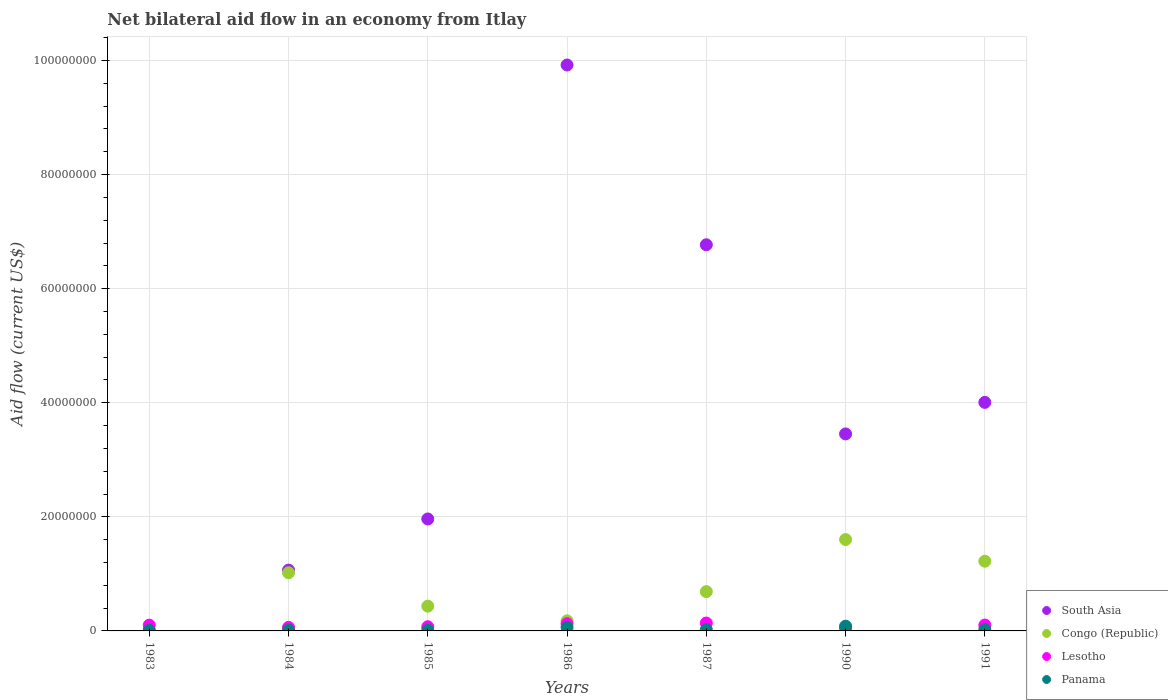Is the number of dotlines equal to the number of legend labels?
Offer a terse response. No. What is the net bilateral aid flow in South Asia in 1984?
Offer a terse response. 1.07e+07. Across all years, what is the maximum net bilateral aid flow in South Asia?
Offer a terse response. 9.92e+07. Across all years, what is the minimum net bilateral aid flow in Congo (Republic)?
Ensure brevity in your answer.  9.00e+04. What is the total net bilateral aid flow in South Asia in the graph?
Provide a short and direct response. 2.72e+08. What is the difference between the net bilateral aid flow in Panama in 1985 and that in 1990?
Make the answer very short. -7.20e+05. What is the difference between the net bilateral aid flow in Lesotho in 1984 and the net bilateral aid flow in Panama in 1990?
Keep it short and to the point. -2.10e+05. What is the average net bilateral aid flow in Lesotho per year?
Give a very brief answer. 9.24e+05. In the year 1987, what is the difference between the net bilateral aid flow in Lesotho and net bilateral aid flow in Panama?
Ensure brevity in your answer.  1.15e+06. In how many years, is the net bilateral aid flow in Congo (Republic) greater than 52000000 US$?
Offer a very short reply. 0. What is the ratio of the net bilateral aid flow in Lesotho in 1984 to that in 1990?
Provide a succinct answer. 1.41. Is the net bilateral aid flow in Congo (Republic) in 1986 less than that in 1987?
Ensure brevity in your answer.  Yes. Is the difference between the net bilateral aid flow in Lesotho in 1983 and 1987 greater than the difference between the net bilateral aid flow in Panama in 1983 and 1987?
Your answer should be compact. No. What is the difference between the highest and the lowest net bilateral aid flow in Congo (Republic)?
Provide a short and direct response. 1.59e+07. In how many years, is the net bilateral aid flow in South Asia greater than the average net bilateral aid flow in South Asia taken over all years?
Make the answer very short. 3. Is the sum of the net bilateral aid flow in Panama in 1983 and 1991 greater than the maximum net bilateral aid flow in Congo (Republic) across all years?
Provide a succinct answer. No. Does the net bilateral aid flow in Panama monotonically increase over the years?
Give a very brief answer. No. Is the net bilateral aid flow in South Asia strictly greater than the net bilateral aid flow in Panama over the years?
Give a very brief answer. No. Is the net bilateral aid flow in South Asia strictly less than the net bilateral aid flow in Lesotho over the years?
Ensure brevity in your answer.  No. How many dotlines are there?
Ensure brevity in your answer.  4. What is the difference between two consecutive major ticks on the Y-axis?
Make the answer very short. 2.00e+07. Are the values on the major ticks of Y-axis written in scientific E-notation?
Ensure brevity in your answer.  No. Does the graph contain any zero values?
Your answer should be compact. Yes. Does the graph contain grids?
Make the answer very short. Yes. How many legend labels are there?
Provide a short and direct response. 4. How are the legend labels stacked?
Offer a terse response. Vertical. What is the title of the graph?
Offer a very short reply. Net bilateral aid flow in an economy from Itlay. What is the label or title of the X-axis?
Offer a very short reply. Years. What is the label or title of the Y-axis?
Offer a terse response. Aid flow (current US$). What is the Aid flow (current US$) in South Asia in 1983?
Your response must be concise. 0. What is the Aid flow (current US$) in Congo (Republic) in 1983?
Ensure brevity in your answer.  9.00e+04. What is the Aid flow (current US$) in Lesotho in 1983?
Provide a short and direct response. 1.01e+06. What is the Aid flow (current US$) of Panama in 1983?
Ensure brevity in your answer.  1.00e+05. What is the Aid flow (current US$) of South Asia in 1984?
Provide a short and direct response. 1.07e+07. What is the Aid flow (current US$) of Congo (Republic) in 1984?
Your response must be concise. 1.02e+07. What is the Aid flow (current US$) of Lesotho in 1984?
Provide a succinct answer. 6.20e+05. What is the Aid flow (current US$) of South Asia in 1985?
Your answer should be compact. 1.96e+07. What is the Aid flow (current US$) in Congo (Republic) in 1985?
Your answer should be very brief. 4.34e+06. What is the Aid flow (current US$) of Lesotho in 1985?
Keep it short and to the point. 7.30e+05. What is the Aid flow (current US$) in Panama in 1985?
Provide a short and direct response. 1.10e+05. What is the Aid flow (current US$) of South Asia in 1986?
Provide a short and direct response. 9.92e+07. What is the Aid flow (current US$) in Congo (Republic) in 1986?
Your response must be concise. 1.77e+06. What is the Aid flow (current US$) of Lesotho in 1986?
Make the answer very short. 1.26e+06. What is the Aid flow (current US$) of Panama in 1986?
Give a very brief answer. 6.30e+05. What is the Aid flow (current US$) in South Asia in 1987?
Provide a short and direct response. 6.77e+07. What is the Aid flow (current US$) of Congo (Republic) in 1987?
Offer a very short reply. 6.89e+06. What is the Aid flow (current US$) of Lesotho in 1987?
Give a very brief answer. 1.38e+06. What is the Aid flow (current US$) of Panama in 1987?
Your answer should be very brief. 2.30e+05. What is the Aid flow (current US$) of South Asia in 1990?
Your answer should be very brief. 3.45e+07. What is the Aid flow (current US$) in Congo (Republic) in 1990?
Your answer should be compact. 1.60e+07. What is the Aid flow (current US$) of Lesotho in 1990?
Your answer should be very brief. 4.40e+05. What is the Aid flow (current US$) of Panama in 1990?
Make the answer very short. 8.30e+05. What is the Aid flow (current US$) in South Asia in 1991?
Your response must be concise. 4.01e+07. What is the Aid flow (current US$) in Congo (Republic) in 1991?
Provide a succinct answer. 1.22e+07. What is the Aid flow (current US$) in Lesotho in 1991?
Provide a short and direct response. 1.03e+06. What is the Aid flow (current US$) in Panama in 1991?
Your response must be concise. 2.20e+05. Across all years, what is the maximum Aid flow (current US$) in South Asia?
Make the answer very short. 9.92e+07. Across all years, what is the maximum Aid flow (current US$) in Congo (Republic)?
Your answer should be compact. 1.60e+07. Across all years, what is the maximum Aid flow (current US$) in Lesotho?
Your answer should be compact. 1.38e+06. Across all years, what is the maximum Aid flow (current US$) in Panama?
Your answer should be compact. 8.30e+05. Across all years, what is the minimum Aid flow (current US$) in South Asia?
Your answer should be compact. 0. Across all years, what is the minimum Aid flow (current US$) in Lesotho?
Give a very brief answer. 4.40e+05. What is the total Aid flow (current US$) in South Asia in the graph?
Offer a terse response. 2.72e+08. What is the total Aid flow (current US$) of Congo (Republic) in the graph?
Offer a very short reply. 5.15e+07. What is the total Aid flow (current US$) in Lesotho in the graph?
Give a very brief answer. 6.47e+06. What is the total Aid flow (current US$) of Panama in the graph?
Keep it short and to the point. 2.26e+06. What is the difference between the Aid flow (current US$) of Congo (Republic) in 1983 and that in 1984?
Provide a short and direct response. -1.01e+07. What is the difference between the Aid flow (current US$) in Congo (Republic) in 1983 and that in 1985?
Your response must be concise. -4.25e+06. What is the difference between the Aid flow (current US$) of Lesotho in 1983 and that in 1985?
Give a very brief answer. 2.80e+05. What is the difference between the Aid flow (current US$) in Congo (Republic) in 1983 and that in 1986?
Your response must be concise. -1.68e+06. What is the difference between the Aid flow (current US$) in Panama in 1983 and that in 1986?
Your response must be concise. -5.30e+05. What is the difference between the Aid flow (current US$) of Congo (Republic) in 1983 and that in 1987?
Provide a succinct answer. -6.80e+06. What is the difference between the Aid flow (current US$) of Lesotho in 1983 and that in 1987?
Provide a succinct answer. -3.70e+05. What is the difference between the Aid flow (current US$) of Congo (Republic) in 1983 and that in 1990?
Ensure brevity in your answer.  -1.59e+07. What is the difference between the Aid flow (current US$) of Lesotho in 1983 and that in 1990?
Provide a short and direct response. 5.70e+05. What is the difference between the Aid flow (current US$) in Panama in 1983 and that in 1990?
Your response must be concise. -7.30e+05. What is the difference between the Aid flow (current US$) in Congo (Republic) in 1983 and that in 1991?
Provide a succinct answer. -1.21e+07. What is the difference between the Aid flow (current US$) of Lesotho in 1983 and that in 1991?
Your response must be concise. -2.00e+04. What is the difference between the Aid flow (current US$) of South Asia in 1984 and that in 1985?
Provide a succinct answer. -8.97e+06. What is the difference between the Aid flow (current US$) of Congo (Republic) in 1984 and that in 1985?
Your answer should be compact. 5.86e+06. What is the difference between the Aid flow (current US$) in Lesotho in 1984 and that in 1985?
Your answer should be compact. -1.10e+05. What is the difference between the Aid flow (current US$) in Panama in 1984 and that in 1985?
Keep it short and to the point. 3.00e+04. What is the difference between the Aid flow (current US$) of South Asia in 1984 and that in 1986?
Ensure brevity in your answer.  -8.86e+07. What is the difference between the Aid flow (current US$) of Congo (Republic) in 1984 and that in 1986?
Your answer should be compact. 8.43e+06. What is the difference between the Aid flow (current US$) in Lesotho in 1984 and that in 1986?
Your answer should be compact. -6.40e+05. What is the difference between the Aid flow (current US$) in Panama in 1984 and that in 1986?
Your answer should be very brief. -4.90e+05. What is the difference between the Aid flow (current US$) of South Asia in 1984 and that in 1987?
Your answer should be compact. -5.70e+07. What is the difference between the Aid flow (current US$) in Congo (Republic) in 1984 and that in 1987?
Provide a succinct answer. 3.31e+06. What is the difference between the Aid flow (current US$) in Lesotho in 1984 and that in 1987?
Provide a succinct answer. -7.60e+05. What is the difference between the Aid flow (current US$) of South Asia in 1984 and that in 1990?
Offer a terse response. -2.39e+07. What is the difference between the Aid flow (current US$) of Congo (Republic) in 1984 and that in 1990?
Offer a very short reply. -5.82e+06. What is the difference between the Aid flow (current US$) in Panama in 1984 and that in 1990?
Offer a terse response. -6.90e+05. What is the difference between the Aid flow (current US$) of South Asia in 1984 and that in 1991?
Keep it short and to the point. -2.94e+07. What is the difference between the Aid flow (current US$) of Congo (Republic) in 1984 and that in 1991?
Provide a succinct answer. -2.02e+06. What is the difference between the Aid flow (current US$) of Lesotho in 1984 and that in 1991?
Ensure brevity in your answer.  -4.10e+05. What is the difference between the Aid flow (current US$) of South Asia in 1985 and that in 1986?
Provide a short and direct response. -7.96e+07. What is the difference between the Aid flow (current US$) of Congo (Republic) in 1985 and that in 1986?
Provide a succinct answer. 2.57e+06. What is the difference between the Aid flow (current US$) of Lesotho in 1985 and that in 1986?
Keep it short and to the point. -5.30e+05. What is the difference between the Aid flow (current US$) in Panama in 1985 and that in 1986?
Your response must be concise. -5.20e+05. What is the difference between the Aid flow (current US$) in South Asia in 1985 and that in 1987?
Provide a short and direct response. -4.81e+07. What is the difference between the Aid flow (current US$) of Congo (Republic) in 1985 and that in 1987?
Provide a succinct answer. -2.55e+06. What is the difference between the Aid flow (current US$) in Lesotho in 1985 and that in 1987?
Provide a short and direct response. -6.50e+05. What is the difference between the Aid flow (current US$) of Panama in 1985 and that in 1987?
Make the answer very short. -1.20e+05. What is the difference between the Aid flow (current US$) in South Asia in 1985 and that in 1990?
Your answer should be compact. -1.49e+07. What is the difference between the Aid flow (current US$) in Congo (Republic) in 1985 and that in 1990?
Offer a terse response. -1.17e+07. What is the difference between the Aid flow (current US$) of Lesotho in 1985 and that in 1990?
Offer a terse response. 2.90e+05. What is the difference between the Aid flow (current US$) in Panama in 1985 and that in 1990?
Ensure brevity in your answer.  -7.20e+05. What is the difference between the Aid flow (current US$) in South Asia in 1985 and that in 1991?
Provide a short and direct response. -2.04e+07. What is the difference between the Aid flow (current US$) of Congo (Republic) in 1985 and that in 1991?
Keep it short and to the point. -7.88e+06. What is the difference between the Aid flow (current US$) in Lesotho in 1985 and that in 1991?
Ensure brevity in your answer.  -3.00e+05. What is the difference between the Aid flow (current US$) of South Asia in 1986 and that in 1987?
Keep it short and to the point. 3.15e+07. What is the difference between the Aid flow (current US$) in Congo (Republic) in 1986 and that in 1987?
Your answer should be very brief. -5.12e+06. What is the difference between the Aid flow (current US$) of Lesotho in 1986 and that in 1987?
Your response must be concise. -1.20e+05. What is the difference between the Aid flow (current US$) in South Asia in 1986 and that in 1990?
Your answer should be compact. 6.47e+07. What is the difference between the Aid flow (current US$) of Congo (Republic) in 1986 and that in 1990?
Provide a short and direct response. -1.42e+07. What is the difference between the Aid flow (current US$) in Lesotho in 1986 and that in 1990?
Your answer should be compact. 8.20e+05. What is the difference between the Aid flow (current US$) of Panama in 1986 and that in 1990?
Offer a terse response. -2.00e+05. What is the difference between the Aid flow (current US$) in South Asia in 1986 and that in 1991?
Provide a succinct answer. 5.92e+07. What is the difference between the Aid flow (current US$) in Congo (Republic) in 1986 and that in 1991?
Your answer should be very brief. -1.04e+07. What is the difference between the Aid flow (current US$) in South Asia in 1987 and that in 1990?
Keep it short and to the point. 3.32e+07. What is the difference between the Aid flow (current US$) of Congo (Republic) in 1987 and that in 1990?
Offer a terse response. -9.13e+06. What is the difference between the Aid flow (current US$) in Lesotho in 1987 and that in 1990?
Provide a succinct answer. 9.40e+05. What is the difference between the Aid flow (current US$) of Panama in 1987 and that in 1990?
Your answer should be very brief. -6.00e+05. What is the difference between the Aid flow (current US$) of South Asia in 1987 and that in 1991?
Offer a very short reply. 2.76e+07. What is the difference between the Aid flow (current US$) in Congo (Republic) in 1987 and that in 1991?
Your response must be concise. -5.33e+06. What is the difference between the Aid flow (current US$) in Lesotho in 1987 and that in 1991?
Provide a short and direct response. 3.50e+05. What is the difference between the Aid flow (current US$) in South Asia in 1990 and that in 1991?
Give a very brief answer. -5.53e+06. What is the difference between the Aid flow (current US$) in Congo (Republic) in 1990 and that in 1991?
Your answer should be compact. 3.80e+06. What is the difference between the Aid flow (current US$) of Lesotho in 1990 and that in 1991?
Your response must be concise. -5.90e+05. What is the difference between the Aid flow (current US$) in Congo (Republic) in 1983 and the Aid flow (current US$) in Lesotho in 1984?
Offer a terse response. -5.30e+05. What is the difference between the Aid flow (current US$) in Congo (Republic) in 1983 and the Aid flow (current US$) in Panama in 1984?
Your answer should be compact. -5.00e+04. What is the difference between the Aid flow (current US$) in Lesotho in 1983 and the Aid flow (current US$) in Panama in 1984?
Make the answer very short. 8.70e+05. What is the difference between the Aid flow (current US$) in Congo (Republic) in 1983 and the Aid flow (current US$) in Lesotho in 1985?
Keep it short and to the point. -6.40e+05. What is the difference between the Aid flow (current US$) in Congo (Republic) in 1983 and the Aid flow (current US$) in Lesotho in 1986?
Offer a terse response. -1.17e+06. What is the difference between the Aid flow (current US$) in Congo (Republic) in 1983 and the Aid flow (current US$) in Panama in 1986?
Your answer should be very brief. -5.40e+05. What is the difference between the Aid flow (current US$) in Lesotho in 1983 and the Aid flow (current US$) in Panama in 1986?
Your answer should be very brief. 3.80e+05. What is the difference between the Aid flow (current US$) of Congo (Republic) in 1983 and the Aid flow (current US$) of Lesotho in 1987?
Offer a very short reply. -1.29e+06. What is the difference between the Aid flow (current US$) in Lesotho in 1983 and the Aid flow (current US$) in Panama in 1987?
Provide a succinct answer. 7.80e+05. What is the difference between the Aid flow (current US$) of Congo (Republic) in 1983 and the Aid flow (current US$) of Lesotho in 1990?
Ensure brevity in your answer.  -3.50e+05. What is the difference between the Aid flow (current US$) in Congo (Republic) in 1983 and the Aid flow (current US$) in Panama in 1990?
Provide a succinct answer. -7.40e+05. What is the difference between the Aid flow (current US$) in Lesotho in 1983 and the Aid flow (current US$) in Panama in 1990?
Give a very brief answer. 1.80e+05. What is the difference between the Aid flow (current US$) in Congo (Republic) in 1983 and the Aid flow (current US$) in Lesotho in 1991?
Your answer should be very brief. -9.40e+05. What is the difference between the Aid flow (current US$) in Lesotho in 1983 and the Aid flow (current US$) in Panama in 1991?
Give a very brief answer. 7.90e+05. What is the difference between the Aid flow (current US$) in South Asia in 1984 and the Aid flow (current US$) in Congo (Republic) in 1985?
Provide a short and direct response. 6.32e+06. What is the difference between the Aid flow (current US$) of South Asia in 1984 and the Aid flow (current US$) of Lesotho in 1985?
Keep it short and to the point. 9.93e+06. What is the difference between the Aid flow (current US$) of South Asia in 1984 and the Aid flow (current US$) of Panama in 1985?
Ensure brevity in your answer.  1.06e+07. What is the difference between the Aid flow (current US$) in Congo (Republic) in 1984 and the Aid flow (current US$) in Lesotho in 1985?
Ensure brevity in your answer.  9.47e+06. What is the difference between the Aid flow (current US$) of Congo (Republic) in 1984 and the Aid flow (current US$) of Panama in 1985?
Offer a very short reply. 1.01e+07. What is the difference between the Aid flow (current US$) in Lesotho in 1984 and the Aid flow (current US$) in Panama in 1985?
Your answer should be very brief. 5.10e+05. What is the difference between the Aid flow (current US$) in South Asia in 1984 and the Aid flow (current US$) in Congo (Republic) in 1986?
Keep it short and to the point. 8.89e+06. What is the difference between the Aid flow (current US$) of South Asia in 1984 and the Aid flow (current US$) of Lesotho in 1986?
Your response must be concise. 9.40e+06. What is the difference between the Aid flow (current US$) of South Asia in 1984 and the Aid flow (current US$) of Panama in 1986?
Offer a very short reply. 1.00e+07. What is the difference between the Aid flow (current US$) in Congo (Republic) in 1984 and the Aid flow (current US$) in Lesotho in 1986?
Ensure brevity in your answer.  8.94e+06. What is the difference between the Aid flow (current US$) of Congo (Republic) in 1984 and the Aid flow (current US$) of Panama in 1986?
Provide a succinct answer. 9.57e+06. What is the difference between the Aid flow (current US$) of South Asia in 1984 and the Aid flow (current US$) of Congo (Republic) in 1987?
Make the answer very short. 3.77e+06. What is the difference between the Aid flow (current US$) of South Asia in 1984 and the Aid flow (current US$) of Lesotho in 1987?
Offer a terse response. 9.28e+06. What is the difference between the Aid flow (current US$) of South Asia in 1984 and the Aid flow (current US$) of Panama in 1987?
Offer a very short reply. 1.04e+07. What is the difference between the Aid flow (current US$) in Congo (Republic) in 1984 and the Aid flow (current US$) in Lesotho in 1987?
Provide a succinct answer. 8.82e+06. What is the difference between the Aid flow (current US$) in Congo (Republic) in 1984 and the Aid flow (current US$) in Panama in 1987?
Ensure brevity in your answer.  9.97e+06. What is the difference between the Aid flow (current US$) of Lesotho in 1984 and the Aid flow (current US$) of Panama in 1987?
Your answer should be compact. 3.90e+05. What is the difference between the Aid flow (current US$) of South Asia in 1984 and the Aid flow (current US$) of Congo (Republic) in 1990?
Provide a succinct answer. -5.36e+06. What is the difference between the Aid flow (current US$) of South Asia in 1984 and the Aid flow (current US$) of Lesotho in 1990?
Offer a very short reply. 1.02e+07. What is the difference between the Aid flow (current US$) in South Asia in 1984 and the Aid flow (current US$) in Panama in 1990?
Provide a short and direct response. 9.83e+06. What is the difference between the Aid flow (current US$) in Congo (Republic) in 1984 and the Aid flow (current US$) in Lesotho in 1990?
Offer a terse response. 9.76e+06. What is the difference between the Aid flow (current US$) in Congo (Republic) in 1984 and the Aid flow (current US$) in Panama in 1990?
Keep it short and to the point. 9.37e+06. What is the difference between the Aid flow (current US$) in South Asia in 1984 and the Aid flow (current US$) in Congo (Republic) in 1991?
Keep it short and to the point. -1.56e+06. What is the difference between the Aid flow (current US$) of South Asia in 1984 and the Aid flow (current US$) of Lesotho in 1991?
Offer a very short reply. 9.63e+06. What is the difference between the Aid flow (current US$) in South Asia in 1984 and the Aid flow (current US$) in Panama in 1991?
Provide a succinct answer. 1.04e+07. What is the difference between the Aid flow (current US$) of Congo (Republic) in 1984 and the Aid flow (current US$) of Lesotho in 1991?
Your response must be concise. 9.17e+06. What is the difference between the Aid flow (current US$) of Congo (Republic) in 1984 and the Aid flow (current US$) of Panama in 1991?
Offer a very short reply. 9.98e+06. What is the difference between the Aid flow (current US$) of South Asia in 1985 and the Aid flow (current US$) of Congo (Republic) in 1986?
Keep it short and to the point. 1.79e+07. What is the difference between the Aid flow (current US$) of South Asia in 1985 and the Aid flow (current US$) of Lesotho in 1986?
Offer a terse response. 1.84e+07. What is the difference between the Aid flow (current US$) in South Asia in 1985 and the Aid flow (current US$) in Panama in 1986?
Provide a short and direct response. 1.90e+07. What is the difference between the Aid flow (current US$) in Congo (Republic) in 1985 and the Aid flow (current US$) in Lesotho in 1986?
Give a very brief answer. 3.08e+06. What is the difference between the Aid flow (current US$) in Congo (Republic) in 1985 and the Aid flow (current US$) in Panama in 1986?
Keep it short and to the point. 3.71e+06. What is the difference between the Aid flow (current US$) of South Asia in 1985 and the Aid flow (current US$) of Congo (Republic) in 1987?
Ensure brevity in your answer.  1.27e+07. What is the difference between the Aid flow (current US$) in South Asia in 1985 and the Aid flow (current US$) in Lesotho in 1987?
Give a very brief answer. 1.82e+07. What is the difference between the Aid flow (current US$) in South Asia in 1985 and the Aid flow (current US$) in Panama in 1987?
Make the answer very short. 1.94e+07. What is the difference between the Aid flow (current US$) in Congo (Republic) in 1985 and the Aid flow (current US$) in Lesotho in 1987?
Provide a succinct answer. 2.96e+06. What is the difference between the Aid flow (current US$) of Congo (Republic) in 1985 and the Aid flow (current US$) of Panama in 1987?
Make the answer very short. 4.11e+06. What is the difference between the Aid flow (current US$) in Lesotho in 1985 and the Aid flow (current US$) in Panama in 1987?
Give a very brief answer. 5.00e+05. What is the difference between the Aid flow (current US$) of South Asia in 1985 and the Aid flow (current US$) of Congo (Republic) in 1990?
Offer a very short reply. 3.61e+06. What is the difference between the Aid flow (current US$) in South Asia in 1985 and the Aid flow (current US$) in Lesotho in 1990?
Your response must be concise. 1.92e+07. What is the difference between the Aid flow (current US$) of South Asia in 1985 and the Aid flow (current US$) of Panama in 1990?
Your response must be concise. 1.88e+07. What is the difference between the Aid flow (current US$) of Congo (Republic) in 1985 and the Aid flow (current US$) of Lesotho in 1990?
Your response must be concise. 3.90e+06. What is the difference between the Aid flow (current US$) in Congo (Republic) in 1985 and the Aid flow (current US$) in Panama in 1990?
Your response must be concise. 3.51e+06. What is the difference between the Aid flow (current US$) in South Asia in 1985 and the Aid flow (current US$) in Congo (Republic) in 1991?
Provide a succinct answer. 7.41e+06. What is the difference between the Aid flow (current US$) of South Asia in 1985 and the Aid flow (current US$) of Lesotho in 1991?
Provide a short and direct response. 1.86e+07. What is the difference between the Aid flow (current US$) of South Asia in 1985 and the Aid flow (current US$) of Panama in 1991?
Your answer should be compact. 1.94e+07. What is the difference between the Aid flow (current US$) of Congo (Republic) in 1985 and the Aid flow (current US$) of Lesotho in 1991?
Offer a very short reply. 3.31e+06. What is the difference between the Aid flow (current US$) of Congo (Republic) in 1985 and the Aid flow (current US$) of Panama in 1991?
Offer a terse response. 4.12e+06. What is the difference between the Aid flow (current US$) of Lesotho in 1985 and the Aid flow (current US$) of Panama in 1991?
Your answer should be very brief. 5.10e+05. What is the difference between the Aid flow (current US$) in South Asia in 1986 and the Aid flow (current US$) in Congo (Republic) in 1987?
Your response must be concise. 9.23e+07. What is the difference between the Aid flow (current US$) of South Asia in 1986 and the Aid flow (current US$) of Lesotho in 1987?
Your answer should be very brief. 9.78e+07. What is the difference between the Aid flow (current US$) in South Asia in 1986 and the Aid flow (current US$) in Panama in 1987?
Ensure brevity in your answer.  9.90e+07. What is the difference between the Aid flow (current US$) in Congo (Republic) in 1986 and the Aid flow (current US$) in Lesotho in 1987?
Your answer should be compact. 3.90e+05. What is the difference between the Aid flow (current US$) in Congo (Republic) in 1986 and the Aid flow (current US$) in Panama in 1987?
Provide a short and direct response. 1.54e+06. What is the difference between the Aid flow (current US$) of Lesotho in 1986 and the Aid flow (current US$) of Panama in 1987?
Your answer should be very brief. 1.03e+06. What is the difference between the Aid flow (current US$) in South Asia in 1986 and the Aid flow (current US$) in Congo (Republic) in 1990?
Make the answer very short. 8.32e+07. What is the difference between the Aid flow (current US$) in South Asia in 1986 and the Aid flow (current US$) in Lesotho in 1990?
Your response must be concise. 9.88e+07. What is the difference between the Aid flow (current US$) of South Asia in 1986 and the Aid flow (current US$) of Panama in 1990?
Offer a very short reply. 9.84e+07. What is the difference between the Aid flow (current US$) of Congo (Republic) in 1986 and the Aid flow (current US$) of Lesotho in 1990?
Your answer should be compact. 1.33e+06. What is the difference between the Aid flow (current US$) of Congo (Republic) in 1986 and the Aid flow (current US$) of Panama in 1990?
Offer a very short reply. 9.40e+05. What is the difference between the Aid flow (current US$) of South Asia in 1986 and the Aid flow (current US$) of Congo (Republic) in 1991?
Offer a very short reply. 8.70e+07. What is the difference between the Aid flow (current US$) of South Asia in 1986 and the Aid flow (current US$) of Lesotho in 1991?
Keep it short and to the point. 9.82e+07. What is the difference between the Aid flow (current US$) of South Asia in 1986 and the Aid flow (current US$) of Panama in 1991?
Ensure brevity in your answer.  9.90e+07. What is the difference between the Aid flow (current US$) in Congo (Republic) in 1986 and the Aid flow (current US$) in Lesotho in 1991?
Give a very brief answer. 7.40e+05. What is the difference between the Aid flow (current US$) of Congo (Republic) in 1986 and the Aid flow (current US$) of Panama in 1991?
Your answer should be very brief. 1.55e+06. What is the difference between the Aid flow (current US$) of Lesotho in 1986 and the Aid flow (current US$) of Panama in 1991?
Your answer should be compact. 1.04e+06. What is the difference between the Aid flow (current US$) in South Asia in 1987 and the Aid flow (current US$) in Congo (Republic) in 1990?
Your response must be concise. 5.17e+07. What is the difference between the Aid flow (current US$) of South Asia in 1987 and the Aid flow (current US$) of Lesotho in 1990?
Offer a terse response. 6.73e+07. What is the difference between the Aid flow (current US$) in South Asia in 1987 and the Aid flow (current US$) in Panama in 1990?
Keep it short and to the point. 6.69e+07. What is the difference between the Aid flow (current US$) of Congo (Republic) in 1987 and the Aid flow (current US$) of Lesotho in 1990?
Provide a short and direct response. 6.45e+06. What is the difference between the Aid flow (current US$) in Congo (Republic) in 1987 and the Aid flow (current US$) in Panama in 1990?
Offer a terse response. 6.06e+06. What is the difference between the Aid flow (current US$) in Lesotho in 1987 and the Aid flow (current US$) in Panama in 1990?
Provide a short and direct response. 5.50e+05. What is the difference between the Aid flow (current US$) of South Asia in 1987 and the Aid flow (current US$) of Congo (Republic) in 1991?
Keep it short and to the point. 5.55e+07. What is the difference between the Aid flow (current US$) in South Asia in 1987 and the Aid flow (current US$) in Lesotho in 1991?
Give a very brief answer. 6.67e+07. What is the difference between the Aid flow (current US$) in South Asia in 1987 and the Aid flow (current US$) in Panama in 1991?
Offer a terse response. 6.75e+07. What is the difference between the Aid flow (current US$) of Congo (Republic) in 1987 and the Aid flow (current US$) of Lesotho in 1991?
Your answer should be compact. 5.86e+06. What is the difference between the Aid flow (current US$) in Congo (Republic) in 1987 and the Aid flow (current US$) in Panama in 1991?
Your response must be concise. 6.67e+06. What is the difference between the Aid flow (current US$) in Lesotho in 1987 and the Aid flow (current US$) in Panama in 1991?
Provide a short and direct response. 1.16e+06. What is the difference between the Aid flow (current US$) in South Asia in 1990 and the Aid flow (current US$) in Congo (Republic) in 1991?
Offer a terse response. 2.23e+07. What is the difference between the Aid flow (current US$) in South Asia in 1990 and the Aid flow (current US$) in Lesotho in 1991?
Ensure brevity in your answer.  3.35e+07. What is the difference between the Aid flow (current US$) in South Asia in 1990 and the Aid flow (current US$) in Panama in 1991?
Your answer should be very brief. 3.43e+07. What is the difference between the Aid flow (current US$) in Congo (Republic) in 1990 and the Aid flow (current US$) in Lesotho in 1991?
Your answer should be compact. 1.50e+07. What is the difference between the Aid flow (current US$) of Congo (Republic) in 1990 and the Aid flow (current US$) of Panama in 1991?
Provide a succinct answer. 1.58e+07. What is the average Aid flow (current US$) in South Asia per year?
Ensure brevity in your answer.  3.88e+07. What is the average Aid flow (current US$) in Congo (Republic) per year?
Provide a succinct answer. 7.36e+06. What is the average Aid flow (current US$) of Lesotho per year?
Your response must be concise. 9.24e+05. What is the average Aid flow (current US$) in Panama per year?
Make the answer very short. 3.23e+05. In the year 1983, what is the difference between the Aid flow (current US$) in Congo (Republic) and Aid flow (current US$) in Lesotho?
Ensure brevity in your answer.  -9.20e+05. In the year 1983, what is the difference between the Aid flow (current US$) of Lesotho and Aid flow (current US$) of Panama?
Ensure brevity in your answer.  9.10e+05. In the year 1984, what is the difference between the Aid flow (current US$) in South Asia and Aid flow (current US$) in Lesotho?
Provide a short and direct response. 1.00e+07. In the year 1984, what is the difference between the Aid flow (current US$) of South Asia and Aid flow (current US$) of Panama?
Make the answer very short. 1.05e+07. In the year 1984, what is the difference between the Aid flow (current US$) of Congo (Republic) and Aid flow (current US$) of Lesotho?
Your response must be concise. 9.58e+06. In the year 1984, what is the difference between the Aid flow (current US$) of Congo (Republic) and Aid flow (current US$) of Panama?
Your answer should be very brief. 1.01e+07. In the year 1985, what is the difference between the Aid flow (current US$) in South Asia and Aid flow (current US$) in Congo (Republic)?
Make the answer very short. 1.53e+07. In the year 1985, what is the difference between the Aid flow (current US$) in South Asia and Aid flow (current US$) in Lesotho?
Offer a terse response. 1.89e+07. In the year 1985, what is the difference between the Aid flow (current US$) of South Asia and Aid flow (current US$) of Panama?
Your answer should be compact. 1.95e+07. In the year 1985, what is the difference between the Aid flow (current US$) of Congo (Republic) and Aid flow (current US$) of Lesotho?
Your response must be concise. 3.61e+06. In the year 1985, what is the difference between the Aid flow (current US$) of Congo (Republic) and Aid flow (current US$) of Panama?
Provide a short and direct response. 4.23e+06. In the year 1985, what is the difference between the Aid flow (current US$) of Lesotho and Aid flow (current US$) of Panama?
Keep it short and to the point. 6.20e+05. In the year 1986, what is the difference between the Aid flow (current US$) in South Asia and Aid flow (current US$) in Congo (Republic)?
Ensure brevity in your answer.  9.74e+07. In the year 1986, what is the difference between the Aid flow (current US$) in South Asia and Aid flow (current US$) in Lesotho?
Give a very brief answer. 9.80e+07. In the year 1986, what is the difference between the Aid flow (current US$) of South Asia and Aid flow (current US$) of Panama?
Ensure brevity in your answer.  9.86e+07. In the year 1986, what is the difference between the Aid flow (current US$) of Congo (Republic) and Aid flow (current US$) of Lesotho?
Provide a short and direct response. 5.10e+05. In the year 1986, what is the difference between the Aid flow (current US$) in Congo (Republic) and Aid flow (current US$) in Panama?
Offer a very short reply. 1.14e+06. In the year 1986, what is the difference between the Aid flow (current US$) of Lesotho and Aid flow (current US$) of Panama?
Give a very brief answer. 6.30e+05. In the year 1987, what is the difference between the Aid flow (current US$) in South Asia and Aid flow (current US$) in Congo (Republic)?
Give a very brief answer. 6.08e+07. In the year 1987, what is the difference between the Aid flow (current US$) of South Asia and Aid flow (current US$) of Lesotho?
Your answer should be compact. 6.63e+07. In the year 1987, what is the difference between the Aid flow (current US$) in South Asia and Aid flow (current US$) in Panama?
Offer a terse response. 6.75e+07. In the year 1987, what is the difference between the Aid flow (current US$) in Congo (Republic) and Aid flow (current US$) in Lesotho?
Your answer should be very brief. 5.51e+06. In the year 1987, what is the difference between the Aid flow (current US$) of Congo (Republic) and Aid flow (current US$) of Panama?
Provide a succinct answer. 6.66e+06. In the year 1987, what is the difference between the Aid flow (current US$) of Lesotho and Aid flow (current US$) of Panama?
Your answer should be compact. 1.15e+06. In the year 1990, what is the difference between the Aid flow (current US$) of South Asia and Aid flow (current US$) of Congo (Republic)?
Your response must be concise. 1.85e+07. In the year 1990, what is the difference between the Aid flow (current US$) in South Asia and Aid flow (current US$) in Lesotho?
Give a very brief answer. 3.41e+07. In the year 1990, what is the difference between the Aid flow (current US$) of South Asia and Aid flow (current US$) of Panama?
Provide a succinct answer. 3.37e+07. In the year 1990, what is the difference between the Aid flow (current US$) of Congo (Republic) and Aid flow (current US$) of Lesotho?
Keep it short and to the point. 1.56e+07. In the year 1990, what is the difference between the Aid flow (current US$) in Congo (Republic) and Aid flow (current US$) in Panama?
Make the answer very short. 1.52e+07. In the year 1990, what is the difference between the Aid flow (current US$) in Lesotho and Aid flow (current US$) in Panama?
Offer a very short reply. -3.90e+05. In the year 1991, what is the difference between the Aid flow (current US$) in South Asia and Aid flow (current US$) in Congo (Republic)?
Your answer should be very brief. 2.78e+07. In the year 1991, what is the difference between the Aid flow (current US$) in South Asia and Aid flow (current US$) in Lesotho?
Offer a very short reply. 3.90e+07. In the year 1991, what is the difference between the Aid flow (current US$) in South Asia and Aid flow (current US$) in Panama?
Provide a short and direct response. 3.98e+07. In the year 1991, what is the difference between the Aid flow (current US$) of Congo (Republic) and Aid flow (current US$) of Lesotho?
Keep it short and to the point. 1.12e+07. In the year 1991, what is the difference between the Aid flow (current US$) of Lesotho and Aid flow (current US$) of Panama?
Your answer should be very brief. 8.10e+05. What is the ratio of the Aid flow (current US$) in Congo (Republic) in 1983 to that in 1984?
Your response must be concise. 0.01. What is the ratio of the Aid flow (current US$) in Lesotho in 1983 to that in 1984?
Your answer should be compact. 1.63. What is the ratio of the Aid flow (current US$) of Congo (Republic) in 1983 to that in 1985?
Offer a very short reply. 0.02. What is the ratio of the Aid flow (current US$) in Lesotho in 1983 to that in 1985?
Your answer should be compact. 1.38. What is the ratio of the Aid flow (current US$) in Congo (Republic) in 1983 to that in 1986?
Keep it short and to the point. 0.05. What is the ratio of the Aid flow (current US$) of Lesotho in 1983 to that in 1986?
Keep it short and to the point. 0.8. What is the ratio of the Aid flow (current US$) of Panama in 1983 to that in 1986?
Make the answer very short. 0.16. What is the ratio of the Aid flow (current US$) of Congo (Republic) in 1983 to that in 1987?
Provide a succinct answer. 0.01. What is the ratio of the Aid flow (current US$) in Lesotho in 1983 to that in 1987?
Your answer should be compact. 0.73. What is the ratio of the Aid flow (current US$) in Panama in 1983 to that in 1987?
Give a very brief answer. 0.43. What is the ratio of the Aid flow (current US$) in Congo (Republic) in 1983 to that in 1990?
Your response must be concise. 0.01. What is the ratio of the Aid flow (current US$) in Lesotho in 1983 to that in 1990?
Your answer should be very brief. 2.3. What is the ratio of the Aid flow (current US$) of Panama in 1983 to that in 1990?
Your response must be concise. 0.12. What is the ratio of the Aid flow (current US$) in Congo (Republic) in 1983 to that in 1991?
Make the answer very short. 0.01. What is the ratio of the Aid flow (current US$) in Lesotho in 1983 to that in 1991?
Your response must be concise. 0.98. What is the ratio of the Aid flow (current US$) in Panama in 1983 to that in 1991?
Provide a short and direct response. 0.45. What is the ratio of the Aid flow (current US$) of South Asia in 1984 to that in 1985?
Offer a terse response. 0.54. What is the ratio of the Aid flow (current US$) in Congo (Republic) in 1984 to that in 1985?
Provide a succinct answer. 2.35. What is the ratio of the Aid flow (current US$) in Lesotho in 1984 to that in 1985?
Ensure brevity in your answer.  0.85. What is the ratio of the Aid flow (current US$) of Panama in 1984 to that in 1985?
Offer a very short reply. 1.27. What is the ratio of the Aid flow (current US$) in South Asia in 1984 to that in 1986?
Offer a terse response. 0.11. What is the ratio of the Aid flow (current US$) in Congo (Republic) in 1984 to that in 1986?
Offer a very short reply. 5.76. What is the ratio of the Aid flow (current US$) of Lesotho in 1984 to that in 1986?
Provide a short and direct response. 0.49. What is the ratio of the Aid flow (current US$) in Panama in 1984 to that in 1986?
Ensure brevity in your answer.  0.22. What is the ratio of the Aid flow (current US$) in South Asia in 1984 to that in 1987?
Give a very brief answer. 0.16. What is the ratio of the Aid flow (current US$) in Congo (Republic) in 1984 to that in 1987?
Offer a very short reply. 1.48. What is the ratio of the Aid flow (current US$) in Lesotho in 1984 to that in 1987?
Provide a succinct answer. 0.45. What is the ratio of the Aid flow (current US$) in Panama in 1984 to that in 1987?
Offer a terse response. 0.61. What is the ratio of the Aid flow (current US$) in South Asia in 1984 to that in 1990?
Give a very brief answer. 0.31. What is the ratio of the Aid flow (current US$) of Congo (Republic) in 1984 to that in 1990?
Give a very brief answer. 0.64. What is the ratio of the Aid flow (current US$) in Lesotho in 1984 to that in 1990?
Provide a short and direct response. 1.41. What is the ratio of the Aid flow (current US$) in Panama in 1984 to that in 1990?
Your response must be concise. 0.17. What is the ratio of the Aid flow (current US$) of South Asia in 1984 to that in 1991?
Make the answer very short. 0.27. What is the ratio of the Aid flow (current US$) in Congo (Republic) in 1984 to that in 1991?
Your answer should be very brief. 0.83. What is the ratio of the Aid flow (current US$) of Lesotho in 1984 to that in 1991?
Your response must be concise. 0.6. What is the ratio of the Aid flow (current US$) of Panama in 1984 to that in 1991?
Make the answer very short. 0.64. What is the ratio of the Aid flow (current US$) in South Asia in 1985 to that in 1986?
Give a very brief answer. 0.2. What is the ratio of the Aid flow (current US$) in Congo (Republic) in 1985 to that in 1986?
Offer a terse response. 2.45. What is the ratio of the Aid flow (current US$) in Lesotho in 1985 to that in 1986?
Keep it short and to the point. 0.58. What is the ratio of the Aid flow (current US$) in Panama in 1985 to that in 1986?
Ensure brevity in your answer.  0.17. What is the ratio of the Aid flow (current US$) of South Asia in 1985 to that in 1987?
Offer a very short reply. 0.29. What is the ratio of the Aid flow (current US$) in Congo (Republic) in 1985 to that in 1987?
Offer a terse response. 0.63. What is the ratio of the Aid flow (current US$) in Lesotho in 1985 to that in 1987?
Make the answer very short. 0.53. What is the ratio of the Aid flow (current US$) of Panama in 1985 to that in 1987?
Your answer should be compact. 0.48. What is the ratio of the Aid flow (current US$) of South Asia in 1985 to that in 1990?
Offer a very short reply. 0.57. What is the ratio of the Aid flow (current US$) in Congo (Republic) in 1985 to that in 1990?
Provide a short and direct response. 0.27. What is the ratio of the Aid flow (current US$) of Lesotho in 1985 to that in 1990?
Give a very brief answer. 1.66. What is the ratio of the Aid flow (current US$) of Panama in 1985 to that in 1990?
Offer a very short reply. 0.13. What is the ratio of the Aid flow (current US$) of South Asia in 1985 to that in 1991?
Ensure brevity in your answer.  0.49. What is the ratio of the Aid flow (current US$) in Congo (Republic) in 1985 to that in 1991?
Provide a short and direct response. 0.36. What is the ratio of the Aid flow (current US$) in Lesotho in 1985 to that in 1991?
Keep it short and to the point. 0.71. What is the ratio of the Aid flow (current US$) of South Asia in 1986 to that in 1987?
Make the answer very short. 1.47. What is the ratio of the Aid flow (current US$) of Congo (Republic) in 1986 to that in 1987?
Provide a succinct answer. 0.26. What is the ratio of the Aid flow (current US$) in Panama in 1986 to that in 1987?
Your response must be concise. 2.74. What is the ratio of the Aid flow (current US$) of South Asia in 1986 to that in 1990?
Give a very brief answer. 2.87. What is the ratio of the Aid flow (current US$) of Congo (Republic) in 1986 to that in 1990?
Offer a very short reply. 0.11. What is the ratio of the Aid flow (current US$) in Lesotho in 1986 to that in 1990?
Your response must be concise. 2.86. What is the ratio of the Aid flow (current US$) in Panama in 1986 to that in 1990?
Offer a terse response. 0.76. What is the ratio of the Aid flow (current US$) of South Asia in 1986 to that in 1991?
Your answer should be compact. 2.48. What is the ratio of the Aid flow (current US$) in Congo (Republic) in 1986 to that in 1991?
Ensure brevity in your answer.  0.14. What is the ratio of the Aid flow (current US$) of Lesotho in 1986 to that in 1991?
Provide a short and direct response. 1.22. What is the ratio of the Aid flow (current US$) of Panama in 1986 to that in 1991?
Provide a succinct answer. 2.86. What is the ratio of the Aid flow (current US$) of South Asia in 1987 to that in 1990?
Give a very brief answer. 1.96. What is the ratio of the Aid flow (current US$) in Congo (Republic) in 1987 to that in 1990?
Ensure brevity in your answer.  0.43. What is the ratio of the Aid flow (current US$) in Lesotho in 1987 to that in 1990?
Ensure brevity in your answer.  3.14. What is the ratio of the Aid flow (current US$) of Panama in 1987 to that in 1990?
Offer a terse response. 0.28. What is the ratio of the Aid flow (current US$) in South Asia in 1987 to that in 1991?
Offer a very short reply. 1.69. What is the ratio of the Aid flow (current US$) in Congo (Republic) in 1987 to that in 1991?
Keep it short and to the point. 0.56. What is the ratio of the Aid flow (current US$) in Lesotho in 1987 to that in 1991?
Make the answer very short. 1.34. What is the ratio of the Aid flow (current US$) in Panama in 1987 to that in 1991?
Give a very brief answer. 1.05. What is the ratio of the Aid flow (current US$) of South Asia in 1990 to that in 1991?
Offer a terse response. 0.86. What is the ratio of the Aid flow (current US$) in Congo (Republic) in 1990 to that in 1991?
Your response must be concise. 1.31. What is the ratio of the Aid flow (current US$) of Lesotho in 1990 to that in 1991?
Offer a terse response. 0.43. What is the ratio of the Aid flow (current US$) in Panama in 1990 to that in 1991?
Offer a very short reply. 3.77. What is the difference between the highest and the second highest Aid flow (current US$) in South Asia?
Your answer should be compact. 3.15e+07. What is the difference between the highest and the second highest Aid flow (current US$) of Congo (Republic)?
Make the answer very short. 3.80e+06. What is the difference between the highest and the second highest Aid flow (current US$) of Lesotho?
Make the answer very short. 1.20e+05. What is the difference between the highest and the second highest Aid flow (current US$) of Panama?
Provide a short and direct response. 2.00e+05. What is the difference between the highest and the lowest Aid flow (current US$) in South Asia?
Provide a short and direct response. 9.92e+07. What is the difference between the highest and the lowest Aid flow (current US$) of Congo (Republic)?
Your answer should be very brief. 1.59e+07. What is the difference between the highest and the lowest Aid flow (current US$) in Lesotho?
Offer a terse response. 9.40e+05. What is the difference between the highest and the lowest Aid flow (current US$) in Panama?
Ensure brevity in your answer.  7.30e+05. 